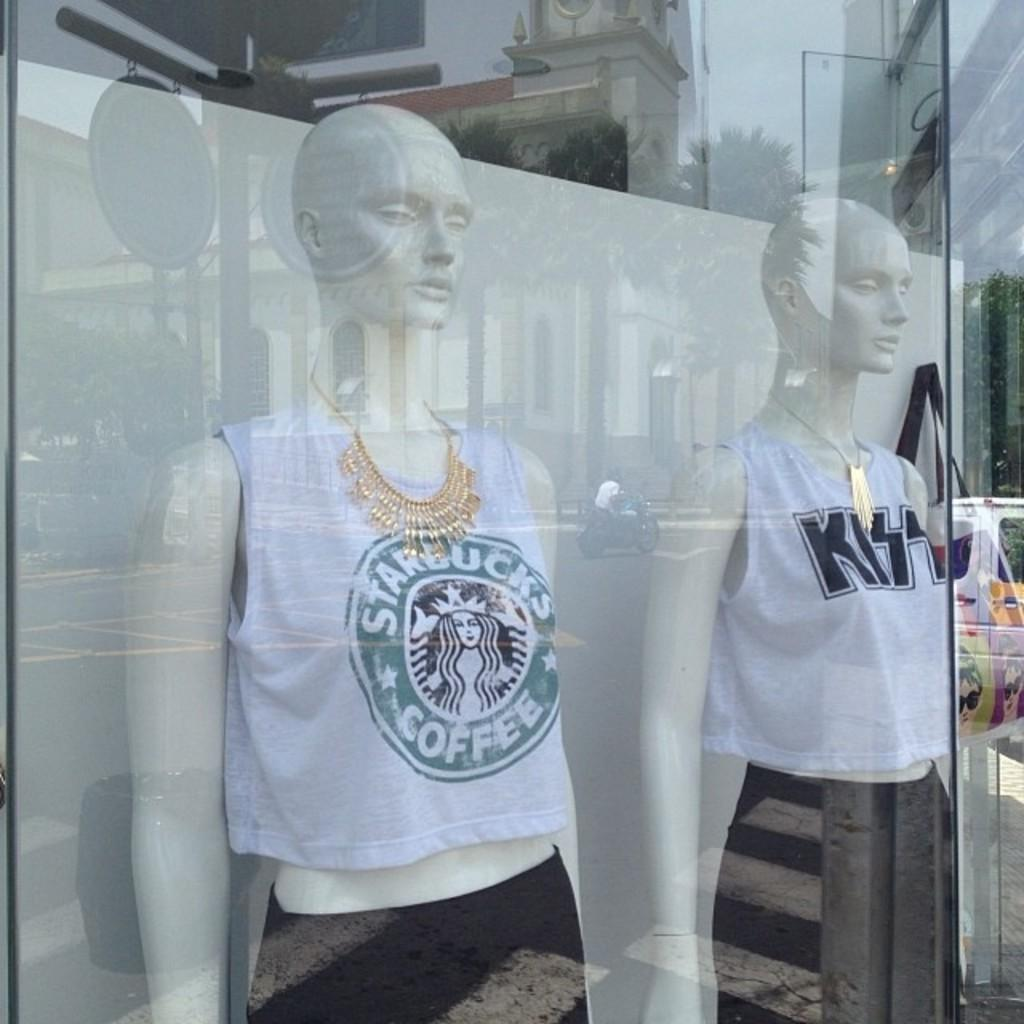<image>
Create a compact narrative representing the image presented. Statue of a person wearing a shirt which says Starbucks Coffee. 